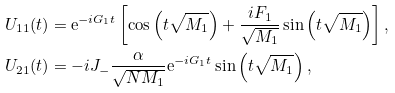<formula> <loc_0><loc_0><loc_500><loc_500>U _ { 1 1 } ( t ) & = \mathrm e ^ { - i G _ { 1 } t } \left [ \cos \left ( t \sqrt { M _ { 1 } } \right ) + \frac { i F _ { 1 } } { \sqrt { M _ { 1 } } } \sin \left ( t \sqrt { M _ { 1 } } \right ) \right ] , \\ U _ { 2 1 } ( t ) & = - i J _ { - } \frac { \alpha } { \sqrt { N M _ { 1 } } } \mathrm e ^ { - i G _ { 1 } t } \sin \left ( t \sqrt { M _ { 1 } } \right ) ,</formula> 